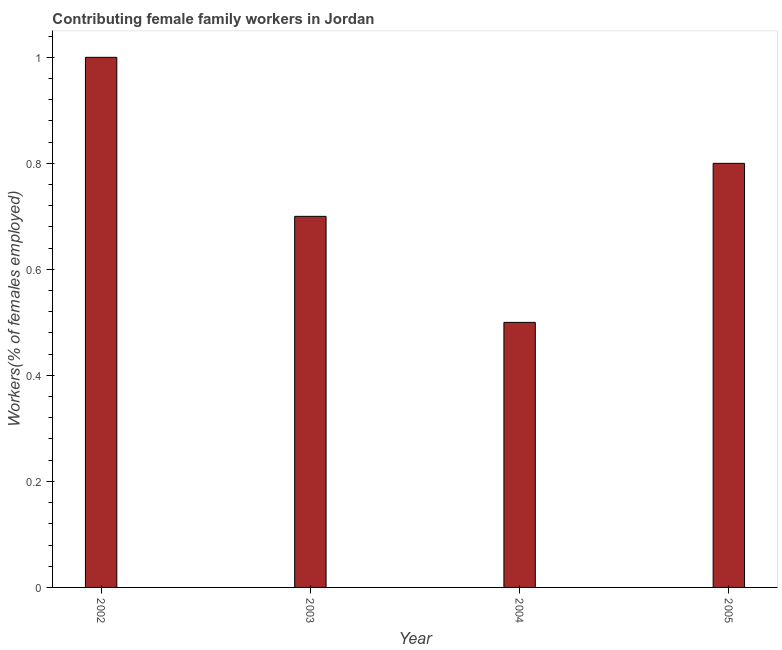Does the graph contain any zero values?
Offer a very short reply. No. What is the title of the graph?
Your answer should be compact. Contributing female family workers in Jordan. What is the label or title of the X-axis?
Make the answer very short. Year. What is the label or title of the Y-axis?
Give a very brief answer. Workers(% of females employed). What is the contributing female family workers in 2004?
Your answer should be very brief. 0.5. Across all years, what is the minimum contributing female family workers?
Offer a terse response. 0.5. In which year was the contributing female family workers minimum?
Your response must be concise. 2004. What is the sum of the contributing female family workers?
Offer a very short reply. 3. What is the median contributing female family workers?
Keep it short and to the point. 0.75. Is the contributing female family workers in 2003 less than that in 2005?
Keep it short and to the point. Yes. What is the difference between the highest and the second highest contributing female family workers?
Your answer should be very brief. 0.2. Is the sum of the contributing female family workers in 2002 and 2003 greater than the maximum contributing female family workers across all years?
Keep it short and to the point. Yes. Are all the bars in the graph horizontal?
Offer a terse response. No. How many years are there in the graph?
Your response must be concise. 4. Are the values on the major ticks of Y-axis written in scientific E-notation?
Provide a short and direct response. No. What is the Workers(% of females employed) in 2002?
Provide a succinct answer. 1. What is the Workers(% of females employed) of 2003?
Your answer should be very brief. 0.7. What is the Workers(% of females employed) in 2005?
Provide a succinct answer. 0.8. What is the difference between the Workers(% of females employed) in 2002 and 2005?
Give a very brief answer. 0.2. What is the difference between the Workers(% of females employed) in 2003 and 2005?
Your response must be concise. -0.1. What is the difference between the Workers(% of females employed) in 2004 and 2005?
Your answer should be compact. -0.3. What is the ratio of the Workers(% of females employed) in 2002 to that in 2003?
Your response must be concise. 1.43. What is the ratio of the Workers(% of females employed) in 2002 to that in 2005?
Offer a terse response. 1.25. What is the ratio of the Workers(% of females employed) in 2004 to that in 2005?
Make the answer very short. 0.62. 